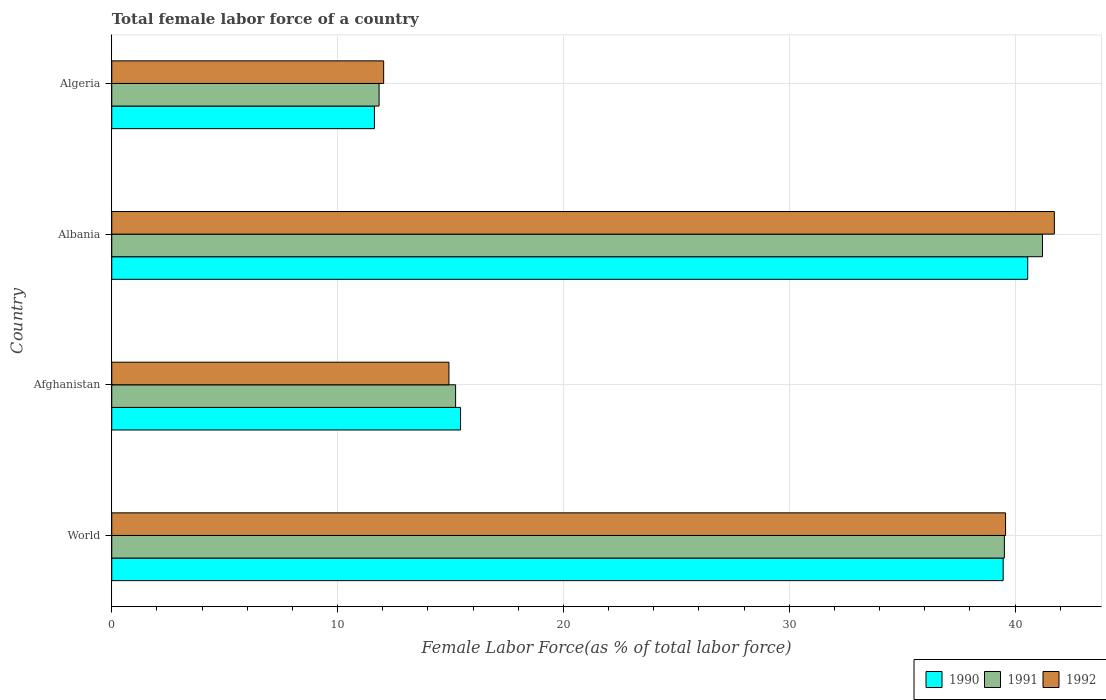How many different coloured bars are there?
Provide a short and direct response. 3. How many groups of bars are there?
Your answer should be compact. 4. How many bars are there on the 3rd tick from the top?
Keep it short and to the point. 3. How many bars are there on the 4th tick from the bottom?
Ensure brevity in your answer.  3. What is the label of the 4th group of bars from the top?
Offer a terse response. World. What is the percentage of female labor force in 1992 in Afghanistan?
Ensure brevity in your answer.  14.93. Across all countries, what is the maximum percentage of female labor force in 1991?
Offer a very short reply. 41.22. Across all countries, what is the minimum percentage of female labor force in 1992?
Your answer should be very brief. 12.04. In which country was the percentage of female labor force in 1992 maximum?
Offer a terse response. Albania. In which country was the percentage of female labor force in 1992 minimum?
Provide a succinct answer. Algeria. What is the total percentage of female labor force in 1991 in the graph?
Keep it short and to the point. 107.81. What is the difference between the percentage of female labor force in 1990 in Albania and that in Algeria?
Provide a short and direct response. 28.93. What is the difference between the percentage of female labor force in 1992 in Algeria and the percentage of female labor force in 1990 in Afghanistan?
Offer a terse response. -3.4. What is the average percentage of female labor force in 1992 per country?
Keep it short and to the point. 27.07. What is the difference between the percentage of female labor force in 1991 and percentage of female labor force in 1992 in World?
Your response must be concise. -0.05. In how many countries, is the percentage of female labor force in 1990 greater than 22 %?
Make the answer very short. 2. What is the ratio of the percentage of female labor force in 1992 in Afghanistan to that in Algeria?
Provide a short and direct response. 1.24. What is the difference between the highest and the second highest percentage of female labor force in 1991?
Your response must be concise. 1.69. What is the difference between the highest and the lowest percentage of female labor force in 1990?
Your answer should be compact. 28.93. What does the 2nd bar from the top in Algeria represents?
Make the answer very short. 1991. What does the 3rd bar from the bottom in Albania represents?
Provide a succinct answer. 1992. How many bars are there?
Provide a short and direct response. 12. Are all the bars in the graph horizontal?
Your answer should be compact. Yes. How many countries are there in the graph?
Offer a very short reply. 4. Are the values on the major ticks of X-axis written in scientific E-notation?
Your answer should be very brief. No. Does the graph contain any zero values?
Offer a very short reply. No. Does the graph contain grids?
Your answer should be compact. Yes. What is the title of the graph?
Make the answer very short. Total female labor force of a country. Does "1960" appear as one of the legend labels in the graph?
Provide a succinct answer. No. What is the label or title of the X-axis?
Provide a succinct answer. Female Labor Force(as % of total labor force). What is the label or title of the Y-axis?
Your response must be concise. Country. What is the Female Labor Force(as % of total labor force) in 1990 in World?
Offer a very short reply. 39.47. What is the Female Labor Force(as % of total labor force) of 1991 in World?
Provide a succinct answer. 39.53. What is the Female Labor Force(as % of total labor force) in 1992 in World?
Keep it short and to the point. 39.58. What is the Female Labor Force(as % of total labor force) of 1990 in Afghanistan?
Your response must be concise. 15.45. What is the Female Labor Force(as % of total labor force) of 1991 in Afghanistan?
Your answer should be very brief. 15.23. What is the Female Labor Force(as % of total labor force) of 1992 in Afghanistan?
Ensure brevity in your answer.  14.93. What is the Female Labor Force(as % of total labor force) in 1990 in Albania?
Offer a terse response. 40.56. What is the Female Labor Force(as % of total labor force) in 1991 in Albania?
Offer a very short reply. 41.22. What is the Female Labor Force(as % of total labor force) of 1992 in Albania?
Ensure brevity in your answer.  41.74. What is the Female Labor Force(as % of total labor force) of 1990 in Algeria?
Your answer should be compact. 11.63. What is the Female Labor Force(as % of total labor force) of 1991 in Algeria?
Your response must be concise. 11.84. What is the Female Labor Force(as % of total labor force) in 1992 in Algeria?
Your response must be concise. 12.04. Across all countries, what is the maximum Female Labor Force(as % of total labor force) in 1990?
Provide a succinct answer. 40.56. Across all countries, what is the maximum Female Labor Force(as % of total labor force) in 1991?
Offer a terse response. 41.22. Across all countries, what is the maximum Female Labor Force(as % of total labor force) in 1992?
Keep it short and to the point. 41.74. Across all countries, what is the minimum Female Labor Force(as % of total labor force) of 1990?
Offer a very short reply. 11.63. Across all countries, what is the minimum Female Labor Force(as % of total labor force) in 1991?
Ensure brevity in your answer.  11.84. Across all countries, what is the minimum Female Labor Force(as % of total labor force) in 1992?
Provide a short and direct response. 12.04. What is the total Female Labor Force(as % of total labor force) of 1990 in the graph?
Make the answer very short. 107.11. What is the total Female Labor Force(as % of total labor force) in 1991 in the graph?
Provide a short and direct response. 107.81. What is the total Female Labor Force(as % of total labor force) of 1992 in the graph?
Your answer should be compact. 108.3. What is the difference between the Female Labor Force(as % of total labor force) of 1990 in World and that in Afghanistan?
Provide a short and direct response. 24.03. What is the difference between the Female Labor Force(as % of total labor force) of 1991 in World and that in Afghanistan?
Offer a terse response. 24.3. What is the difference between the Female Labor Force(as % of total labor force) of 1992 in World and that in Afghanistan?
Provide a succinct answer. 24.65. What is the difference between the Female Labor Force(as % of total labor force) of 1990 in World and that in Albania?
Offer a terse response. -1.09. What is the difference between the Female Labor Force(as % of total labor force) in 1991 in World and that in Albania?
Offer a very short reply. -1.69. What is the difference between the Female Labor Force(as % of total labor force) in 1992 in World and that in Albania?
Offer a terse response. -2.16. What is the difference between the Female Labor Force(as % of total labor force) of 1990 in World and that in Algeria?
Keep it short and to the point. 27.84. What is the difference between the Female Labor Force(as % of total labor force) in 1991 in World and that in Algeria?
Offer a very short reply. 27.69. What is the difference between the Female Labor Force(as % of total labor force) of 1992 in World and that in Algeria?
Provide a short and direct response. 27.54. What is the difference between the Female Labor Force(as % of total labor force) of 1990 in Afghanistan and that in Albania?
Offer a terse response. -25.12. What is the difference between the Female Labor Force(as % of total labor force) of 1991 in Afghanistan and that in Albania?
Your answer should be compact. -25.99. What is the difference between the Female Labor Force(as % of total labor force) of 1992 in Afghanistan and that in Albania?
Keep it short and to the point. -26.81. What is the difference between the Female Labor Force(as % of total labor force) in 1990 in Afghanistan and that in Algeria?
Give a very brief answer. 3.81. What is the difference between the Female Labor Force(as % of total labor force) of 1991 in Afghanistan and that in Algeria?
Keep it short and to the point. 3.39. What is the difference between the Female Labor Force(as % of total labor force) in 1992 in Afghanistan and that in Algeria?
Ensure brevity in your answer.  2.89. What is the difference between the Female Labor Force(as % of total labor force) in 1990 in Albania and that in Algeria?
Give a very brief answer. 28.93. What is the difference between the Female Labor Force(as % of total labor force) of 1991 in Albania and that in Algeria?
Keep it short and to the point. 29.38. What is the difference between the Female Labor Force(as % of total labor force) in 1992 in Albania and that in Algeria?
Offer a very short reply. 29.7. What is the difference between the Female Labor Force(as % of total labor force) in 1990 in World and the Female Labor Force(as % of total labor force) in 1991 in Afghanistan?
Give a very brief answer. 24.25. What is the difference between the Female Labor Force(as % of total labor force) in 1990 in World and the Female Labor Force(as % of total labor force) in 1992 in Afghanistan?
Offer a very short reply. 24.54. What is the difference between the Female Labor Force(as % of total labor force) of 1991 in World and the Female Labor Force(as % of total labor force) of 1992 in Afghanistan?
Give a very brief answer. 24.6. What is the difference between the Female Labor Force(as % of total labor force) in 1990 in World and the Female Labor Force(as % of total labor force) in 1991 in Albania?
Keep it short and to the point. -1.74. What is the difference between the Female Labor Force(as % of total labor force) of 1990 in World and the Female Labor Force(as % of total labor force) of 1992 in Albania?
Offer a very short reply. -2.27. What is the difference between the Female Labor Force(as % of total labor force) of 1991 in World and the Female Labor Force(as % of total labor force) of 1992 in Albania?
Ensure brevity in your answer.  -2.21. What is the difference between the Female Labor Force(as % of total labor force) in 1990 in World and the Female Labor Force(as % of total labor force) in 1991 in Algeria?
Provide a succinct answer. 27.64. What is the difference between the Female Labor Force(as % of total labor force) of 1990 in World and the Female Labor Force(as % of total labor force) of 1992 in Algeria?
Provide a succinct answer. 27.43. What is the difference between the Female Labor Force(as % of total labor force) of 1991 in World and the Female Labor Force(as % of total labor force) of 1992 in Algeria?
Your response must be concise. 27.49. What is the difference between the Female Labor Force(as % of total labor force) of 1990 in Afghanistan and the Female Labor Force(as % of total labor force) of 1991 in Albania?
Provide a succinct answer. -25.77. What is the difference between the Female Labor Force(as % of total labor force) of 1990 in Afghanistan and the Female Labor Force(as % of total labor force) of 1992 in Albania?
Provide a short and direct response. -26.3. What is the difference between the Female Labor Force(as % of total labor force) of 1991 in Afghanistan and the Female Labor Force(as % of total labor force) of 1992 in Albania?
Keep it short and to the point. -26.51. What is the difference between the Female Labor Force(as % of total labor force) in 1990 in Afghanistan and the Female Labor Force(as % of total labor force) in 1991 in Algeria?
Offer a very short reply. 3.61. What is the difference between the Female Labor Force(as % of total labor force) of 1990 in Afghanistan and the Female Labor Force(as % of total labor force) of 1992 in Algeria?
Make the answer very short. 3.4. What is the difference between the Female Labor Force(as % of total labor force) of 1991 in Afghanistan and the Female Labor Force(as % of total labor force) of 1992 in Algeria?
Your answer should be very brief. 3.19. What is the difference between the Female Labor Force(as % of total labor force) in 1990 in Albania and the Female Labor Force(as % of total labor force) in 1991 in Algeria?
Provide a succinct answer. 28.72. What is the difference between the Female Labor Force(as % of total labor force) of 1990 in Albania and the Female Labor Force(as % of total labor force) of 1992 in Algeria?
Provide a short and direct response. 28.52. What is the difference between the Female Labor Force(as % of total labor force) in 1991 in Albania and the Female Labor Force(as % of total labor force) in 1992 in Algeria?
Provide a short and direct response. 29.17. What is the average Female Labor Force(as % of total labor force) in 1990 per country?
Make the answer very short. 26.78. What is the average Female Labor Force(as % of total labor force) of 1991 per country?
Offer a very short reply. 26.95. What is the average Female Labor Force(as % of total labor force) in 1992 per country?
Make the answer very short. 27.07. What is the difference between the Female Labor Force(as % of total labor force) in 1990 and Female Labor Force(as % of total labor force) in 1991 in World?
Provide a succinct answer. -0.05. What is the difference between the Female Labor Force(as % of total labor force) of 1990 and Female Labor Force(as % of total labor force) of 1992 in World?
Keep it short and to the point. -0.11. What is the difference between the Female Labor Force(as % of total labor force) in 1991 and Female Labor Force(as % of total labor force) in 1992 in World?
Offer a terse response. -0.05. What is the difference between the Female Labor Force(as % of total labor force) in 1990 and Female Labor Force(as % of total labor force) in 1991 in Afghanistan?
Make the answer very short. 0.22. What is the difference between the Female Labor Force(as % of total labor force) in 1990 and Female Labor Force(as % of total labor force) in 1992 in Afghanistan?
Your response must be concise. 0.51. What is the difference between the Female Labor Force(as % of total labor force) in 1991 and Female Labor Force(as % of total labor force) in 1992 in Afghanistan?
Provide a succinct answer. 0.3. What is the difference between the Female Labor Force(as % of total labor force) in 1990 and Female Labor Force(as % of total labor force) in 1991 in Albania?
Give a very brief answer. -0.65. What is the difference between the Female Labor Force(as % of total labor force) in 1990 and Female Labor Force(as % of total labor force) in 1992 in Albania?
Your answer should be compact. -1.18. What is the difference between the Female Labor Force(as % of total labor force) of 1991 and Female Labor Force(as % of total labor force) of 1992 in Albania?
Keep it short and to the point. -0.53. What is the difference between the Female Labor Force(as % of total labor force) in 1990 and Female Labor Force(as % of total labor force) in 1991 in Algeria?
Your answer should be compact. -0.21. What is the difference between the Female Labor Force(as % of total labor force) in 1990 and Female Labor Force(as % of total labor force) in 1992 in Algeria?
Offer a terse response. -0.41. What is the difference between the Female Labor Force(as % of total labor force) of 1991 and Female Labor Force(as % of total labor force) of 1992 in Algeria?
Offer a very short reply. -0.2. What is the ratio of the Female Labor Force(as % of total labor force) in 1990 in World to that in Afghanistan?
Provide a succinct answer. 2.56. What is the ratio of the Female Labor Force(as % of total labor force) of 1991 in World to that in Afghanistan?
Your answer should be very brief. 2.6. What is the ratio of the Female Labor Force(as % of total labor force) in 1992 in World to that in Afghanistan?
Keep it short and to the point. 2.65. What is the ratio of the Female Labor Force(as % of total labor force) of 1990 in World to that in Albania?
Offer a terse response. 0.97. What is the ratio of the Female Labor Force(as % of total labor force) in 1991 in World to that in Albania?
Give a very brief answer. 0.96. What is the ratio of the Female Labor Force(as % of total labor force) of 1992 in World to that in Albania?
Your response must be concise. 0.95. What is the ratio of the Female Labor Force(as % of total labor force) in 1990 in World to that in Algeria?
Provide a short and direct response. 3.39. What is the ratio of the Female Labor Force(as % of total labor force) in 1991 in World to that in Algeria?
Give a very brief answer. 3.34. What is the ratio of the Female Labor Force(as % of total labor force) in 1992 in World to that in Algeria?
Offer a terse response. 3.29. What is the ratio of the Female Labor Force(as % of total labor force) in 1990 in Afghanistan to that in Albania?
Provide a succinct answer. 0.38. What is the ratio of the Female Labor Force(as % of total labor force) in 1991 in Afghanistan to that in Albania?
Your response must be concise. 0.37. What is the ratio of the Female Labor Force(as % of total labor force) of 1992 in Afghanistan to that in Albania?
Your answer should be very brief. 0.36. What is the ratio of the Female Labor Force(as % of total labor force) of 1990 in Afghanistan to that in Algeria?
Provide a short and direct response. 1.33. What is the ratio of the Female Labor Force(as % of total labor force) of 1991 in Afghanistan to that in Algeria?
Your answer should be compact. 1.29. What is the ratio of the Female Labor Force(as % of total labor force) of 1992 in Afghanistan to that in Algeria?
Your answer should be very brief. 1.24. What is the ratio of the Female Labor Force(as % of total labor force) of 1990 in Albania to that in Algeria?
Your answer should be very brief. 3.49. What is the ratio of the Female Labor Force(as % of total labor force) of 1991 in Albania to that in Algeria?
Your answer should be compact. 3.48. What is the ratio of the Female Labor Force(as % of total labor force) in 1992 in Albania to that in Algeria?
Offer a terse response. 3.47. What is the difference between the highest and the second highest Female Labor Force(as % of total labor force) of 1990?
Make the answer very short. 1.09. What is the difference between the highest and the second highest Female Labor Force(as % of total labor force) in 1991?
Give a very brief answer. 1.69. What is the difference between the highest and the second highest Female Labor Force(as % of total labor force) in 1992?
Keep it short and to the point. 2.16. What is the difference between the highest and the lowest Female Labor Force(as % of total labor force) in 1990?
Ensure brevity in your answer.  28.93. What is the difference between the highest and the lowest Female Labor Force(as % of total labor force) in 1991?
Keep it short and to the point. 29.38. What is the difference between the highest and the lowest Female Labor Force(as % of total labor force) of 1992?
Your answer should be compact. 29.7. 